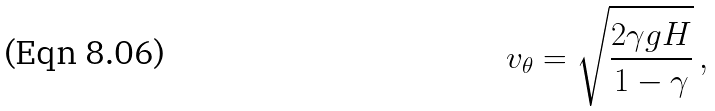<formula> <loc_0><loc_0><loc_500><loc_500>v _ { \theta } = \sqrt { \frac { 2 \gamma g H } { 1 - \gamma } } \, ,</formula> 